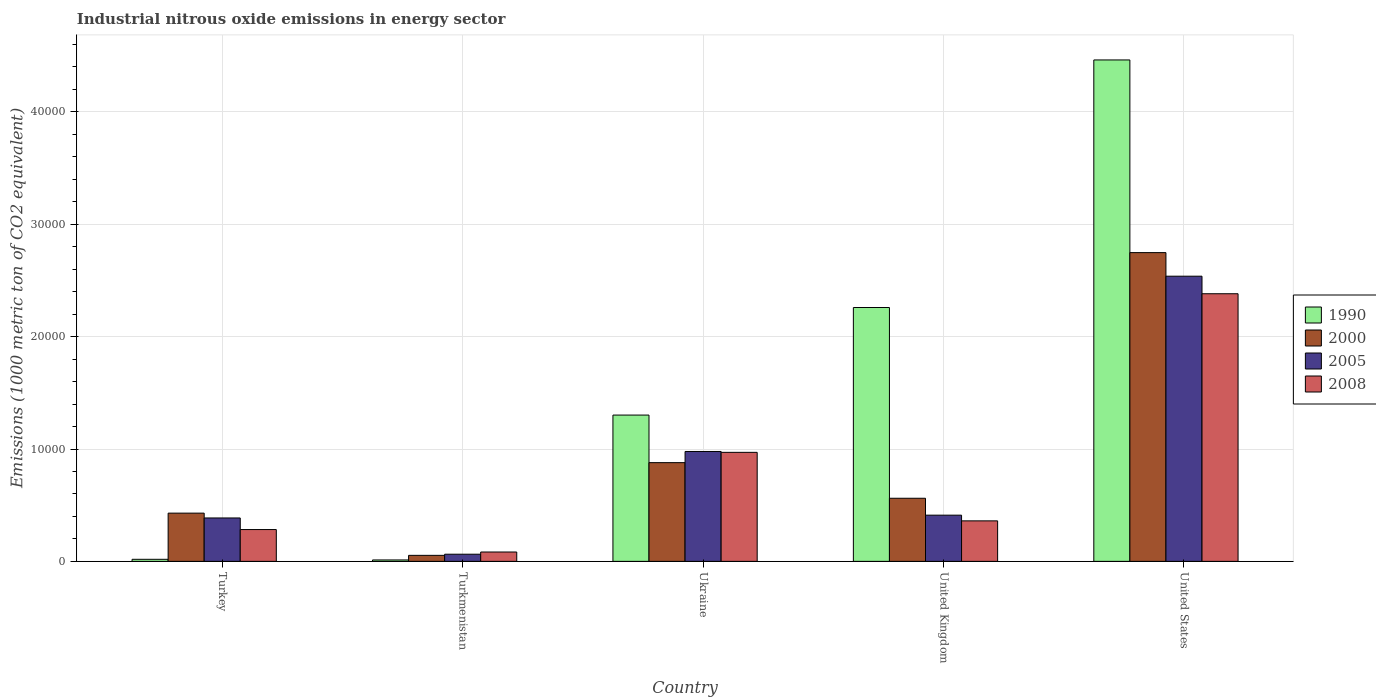How many different coloured bars are there?
Ensure brevity in your answer.  4. Are the number of bars on each tick of the X-axis equal?
Your answer should be compact. Yes. How many bars are there on the 5th tick from the right?
Provide a short and direct response. 4. What is the label of the 5th group of bars from the left?
Your answer should be very brief. United States. In how many cases, is the number of bars for a given country not equal to the number of legend labels?
Your answer should be very brief. 0. What is the amount of industrial nitrous oxide emitted in 1990 in United States?
Offer a terse response. 4.46e+04. Across all countries, what is the maximum amount of industrial nitrous oxide emitted in 1990?
Offer a very short reply. 4.46e+04. Across all countries, what is the minimum amount of industrial nitrous oxide emitted in 2005?
Your answer should be very brief. 637.2. In which country was the amount of industrial nitrous oxide emitted in 2005 maximum?
Offer a terse response. United States. In which country was the amount of industrial nitrous oxide emitted in 2008 minimum?
Your answer should be compact. Turkmenistan. What is the total amount of industrial nitrous oxide emitted in 1990 in the graph?
Make the answer very short. 8.05e+04. What is the difference between the amount of industrial nitrous oxide emitted in 2008 in Turkey and that in United States?
Ensure brevity in your answer.  -2.10e+04. What is the difference between the amount of industrial nitrous oxide emitted in 2000 in United Kingdom and the amount of industrial nitrous oxide emitted in 2005 in United States?
Ensure brevity in your answer.  -1.98e+04. What is the average amount of industrial nitrous oxide emitted in 2005 per country?
Offer a terse response. 8753.94. What is the difference between the amount of industrial nitrous oxide emitted of/in 1990 and amount of industrial nitrous oxide emitted of/in 2000 in Ukraine?
Make the answer very short. 4235.2. What is the ratio of the amount of industrial nitrous oxide emitted in 2000 in Ukraine to that in United Kingdom?
Keep it short and to the point. 1.56. Is the difference between the amount of industrial nitrous oxide emitted in 1990 in Ukraine and United States greater than the difference between the amount of industrial nitrous oxide emitted in 2000 in Ukraine and United States?
Your answer should be compact. No. What is the difference between the highest and the second highest amount of industrial nitrous oxide emitted in 2008?
Offer a very short reply. 2.02e+04. What is the difference between the highest and the lowest amount of industrial nitrous oxide emitted in 2000?
Provide a succinct answer. 2.69e+04. In how many countries, is the amount of industrial nitrous oxide emitted in 2000 greater than the average amount of industrial nitrous oxide emitted in 2000 taken over all countries?
Ensure brevity in your answer.  1. Is the sum of the amount of industrial nitrous oxide emitted in 2005 in Turkey and Turkmenistan greater than the maximum amount of industrial nitrous oxide emitted in 2000 across all countries?
Give a very brief answer. No. Are all the bars in the graph horizontal?
Provide a short and direct response. No. Are the values on the major ticks of Y-axis written in scientific E-notation?
Your response must be concise. No. Does the graph contain grids?
Ensure brevity in your answer.  Yes. Where does the legend appear in the graph?
Your answer should be compact. Center right. How many legend labels are there?
Your answer should be very brief. 4. What is the title of the graph?
Give a very brief answer. Industrial nitrous oxide emissions in energy sector. Does "1973" appear as one of the legend labels in the graph?
Give a very brief answer. No. What is the label or title of the Y-axis?
Your response must be concise. Emissions (1000 metric ton of CO2 equivalent). What is the Emissions (1000 metric ton of CO2 equivalent) of 1990 in Turkey?
Provide a short and direct response. 183.6. What is the Emissions (1000 metric ton of CO2 equivalent) in 2000 in Turkey?
Offer a very short reply. 4292. What is the Emissions (1000 metric ton of CO2 equivalent) of 2005 in Turkey?
Your answer should be very brief. 3862.7. What is the Emissions (1000 metric ton of CO2 equivalent) of 2008 in Turkey?
Ensure brevity in your answer.  2831.3. What is the Emissions (1000 metric ton of CO2 equivalent) of 1990 in Turkmenistan?
Provide a succinct answer. 125.6. What is the Emissions (1000 metric ton of CO2 equivalent) of 2000 in Turkmenistan?
Keep it short and to the point. 535.7. What is the Emissions (1000 metric ton of CO2 equivalent) of 2005 in Turkmenistan?
Your answer should be compact. 637.2. What is the Emissions (1000 metric ton of CO2 equivalent) of 2008 in Turkmenistan?
Your answer should be very brief. 832.5. What is the Emissions (1000 metric ton of CO2 equivalent) in 1990 in Ukraine?
Your answer should be very brief. 1.30e+04. What is the Emissions (1000 metric ton of CO2 equivalent) of 2000 in Ukraine?
Keep it short and to the point. 8784.8. What is the Emissions (1000 metric ton of CO2 equivalent) of 2005 in Ukraine?
Ensure brevity in your answer.  9779.9. What is the Emissions (1000 metric ton of CO2 equivalent) of 2008 in Ukraine?
Your response must be concise. 9701.8. What is the Emissions (1000 metric ton of CO2 equivalent) in 1990 in United Kingdom?
Make the answer very short. 2.26e+04. What is the Emissions (1000 metric ton of CO2 equivalent) in 2000 in United Kingdom?
Provide a succinct answer. 5616. What is the Emissions (1000 metric ton of CO2 equivalent) of 2005 in United Kingdom?
Your answer should be compact. 4111.2. What is the Emissions (1000 metric ton of CO2 equivalent) in 2008 in United Kingdom?
Give a very brief answer. 3604.6. What is the Emissions (1000 metric ton of CO2 equivalent) in 1990 in United States?
Your answer should be compact. 4.46e+04. What is the Emissions (1000 metric ton of CO2 equivalent) in 2000 in United States?
Your answer should be very brief. 2.75e+04. What is the Emissions (1000 metric ton of CO2 equivalent) in 2005 in United States?
Keep it short and to the point. 2.54e+04. What is the Emissions (1000 metric ton of CO2 equivalent) in 2008 in United States?
Provide a short and direct response. 2.38e+04. Across all countries, what is the maximum Emissions (1000 metric ton of CO2 equivalent) of 1990?
Your response must be concise. 4.46e+04. Across all countries, what is the maximum Emissions (1000 metric ton of CO2 equivalent) of 2000?
Ensure brevity in your answer.  2.75e+04. Across all countries, what is the maximum Emissions (1000 metric ton of CO2 equivalent) of 2005?
Provide a succinct answer. 2.54e+04. Across all countries, what is the maximum Emissions (1000 metric ton of CO2 equivalent) in 2008?
Give a very brief answer. 2.38e+04. Across all countries, what is the minimum Emissions (1000 metric ton of CO2 equivalent) in 1990?
Provide a succinct answer. 125.6. Across all countries, what is the minimum Emissions (1000 metric ton of CO2 equivalent) in 2000?
Ensure brevity in your answer.  535.7. Across all countries, what is the minimum Emissions (1000 metric ton of CO2 equivalent) in 2005?
Provide a succinct answer. 637.2. Across all countries, what is the minimum Emissions (1000 metric ton of CO2 equivalent) of 2008?
Provide a short and direct response. 832.5. What is the total Emissions (1000 metric ton of CO2 equivalent) of 1990 in the graph?
Provide a succinct answer. 8.05e+04. What is the total Emissions (1000 metric ton of CO2 equivalent) of 2000 in the graph?
Offer a terse response. 4.67e+04. What is the total Emissions (1000 metric ton of CO2 equivalent) of 2005 in the graph?
Offer a terse response. 4.38e+04. What is the total Emissions (1000 metric ton of CO2 equivalent) of 2008 in the graph?
Make the answer very short. 4.08e+04. What is the difference between the Emissions (1000 metric ton of CO2 equivalent) in 1990 in Turkey and that in Turkmenistan?
Your answer should be very brief. 58. What is the difference between the Emissions (1000 metric ton of CO2 equivalent) of 2000 in Turkey and that in Turkmenistan?
Make the answer very short. 3756.3. What is the difference between the Emissions (1000 metric ton of CO2 equivalent) of 2005 in Turkey and that in Turkmenistan?
Your response must be concise. 3225.5. What is the difference between the Emissions (1000 metric ton of CO2 equivalent) in 2008 in Turkey and that in Turkmenistan?
Keep it short and to the point. 1998.8. What is the difference between the Emissions (1000 metric ton of CO2 equivalent) in 1990 in Turkey and that in Ukraine?
Provide a short and direct response. -1.28e+04. What is the difference between the Emissions (1000 metric ton of CO2 equivalent) in 2000 in Turkey and that in Ukraine?
Give a very brief answer. -4492.8. What is the difference between the Emissions (1000 metric ton of CO2 equivalent) in 2005 in Turkey and that in Ukraine?
Offer a very short reply. -5917.2. What is the difference between the Emissions (1000 metric ton of CO2 equivalent) in 2008 in Turkey and that in Ukraine?
Ensure brevity in your answer.  -6870.5. What is the difference between the Emissions (1000 metric ton of CO2 equivalent) in 1990 in Turkey and that in United Kingdom?
Give a very brief answer. -2.24e+04. What is the difference between the Emissions (1000 metric ton of CO2 equivalent) of 2000 in Turkey and that in United Kingdom?
Provide a short and direct response. -1324. What is the difference between the Emissions (1000 metric ton of CO2 equivalent) of 2005 in Turkey and that in United Kingdom?
Make the answer very short. -248.5. What is the difference between the Emissions (1000 metric ton of CO2 equivalent) in 2008 in Turkey and that in United Kingdom?
Your response must be concise. -773.3. What is the difference between the Emissions (1000 metric ton of CO2 equivalent) in 1990 in Turkey and that in United States?
Offer a very short reply. -4.44e+04. What is the difference between the Emissions (1000 metric ton of CO2 equivalent) of 2000 in Turkey and that in United States?
Offer a very short reply. -2.32e+04. What is the difference between the Emissions (1000 metric ton of CO2 equivalent) of 2005 in Turkey and that in United States?
Your answer should be compact. -2.15e+04. What is the difference between the Emissions (1000 metric ton of CO2 equivalent) in 2008 in Turkey and that in United States?
Provide a succinct answer. -2.10e+04. What is the difference between the Emissions (1000 metric ton of CO2 equivalent) in 1990 in Turkmenistan and that in Ukraine?
Your response must be concise. -1.29e+04. What is the difference between the Emissions (1000 metric ton of CO2 equivalent) of 2000 in Turkmenistan and that in Ukraine?
Ensure brevity in your answer.  -8249.1. What is the difference between the Emissions (1000 metric ton of CO2 equivalent) of 2005 in Turkmenistan and that in Ukraine?
Offer a very short reply. -9142.7. What is the difference between the Emissions (1000 metric ton of CO2 equivalent) of 2008 in Turkmenistan and that in Ukraine?
Make the answer very short. -8869.3. What is the difference between the Emissions (1000 metric ton of CO2 equivalent) in 1990 in Turkmenistan and that in United Kingdom?
Your answer should be very brief. -2.25e+04. What is the difference between the Emissions (1000 metric ton of CO2 equivalent) in 2000 in Turkmenistan and that in United Kingdom?
Keep it short and to the point. -5080.3. What is the difference between the Emissions (1000 metric ton of CO2 equivalent) of 2005 in Turkmenistan and that in United Kingdom?
Provide a succinct answer. -3474. What is the difference between the Emissions (1000 metric ton of CO2 equivalent) of 2008 in Turkmenistan and that in United Kingdom?
Offer a very short reply. -2772.1. What is the difference between the Emissions (1000 metric ton of CO2 equivalent) in 1990 in Turkmenistan and that in United States?
Provide a succinct answer. -4.45e+04. What is the difference between the Emissions (1000 metric ton of CO2 equivalent) of 2000 in Turkmenistan and that in United States?
Your response must be concise. -2.69e+04. What is the difference between the Emissions (1000 metric ton of CO2 equivalent) in 2005 in Turkmenistan and that in United States?
Offer a terse response. -2.47e+04. What is the difference between the Emissions (1000 metric ton of CO2 equivalent) of 2008 in Turkmenistan and that in United States?
Your answer should be compact. -2.30e+04. What is the difference between the Emissions (1000 metric ton of CO2 equivalent) in 1990 in Ukraine and that in United Kingdom?
Your response must be concise. -9573. What is the difference between the Emissions (1000 metric ton of CO2 equivalent) of 2000 in Ukraine and that in United Kingdom?
Give a very brief answer. 3168.8. What is the difference between the Emissions (1000 metric ton of CO2 equivalent) in 2005 in Ukraine and that in United Kingdom?
Offer a very short reply. 5668.7. What is the difference between the Emissions (1000 metric ton of CO2 equivalent) in 2008 in Ukraine and that in United Kingdom?
Your answer should be compact. 6097.2. What is the difference between the Emissions (1000 metric ton of CO2 equivalent) in 1990 in Ukraine and that in United States?
Give a very brief answer. -3.16e+04. What is the difference between the Emissions (1000 metric ton of CO2 equivalent) in 2000 in Ukraine and that in United States?
Provide a succinct answer. -1.87e+04. What is the difference between the Emissions (1000 metric ton of CO2 equivalent) in 2005 in Ukraine and that in United States?
Your answer should be compact. -1.56e+04. What is the difference between the Emissions (1000 metric ton of CO2 equivalent) in 2008 in Ukraine and that in United States?
Your answer should be very brief. -1.41e+04. What is the difference between the Emissions (1000 metric ton of CO2 equivalent) of 1990 in United Kingdom and that in United States?
Your response must be concise. -2.20e+04. What is the difference between the Emissions (1000 metric ton of CO2 equivalent) in 2000 in United Kingdom and that in United States?
Your answer should be compact. -2.19e+04. What is the difference between the Emissions (1000 metric ton of CO2 equivalent) in 2005 in United Kingdom and that in United States?
Offer a terse response. -2.13e+04. What is the difference between the Emissions (1000 metric ton of CO2 equivalent) of 2008 in United Kingdom and that in United States?
Give a very brief answer. -2.02e+04. What is the difference between the Emissions (1000 metric ton of CO2 equivalent) of 1990 in Turkey and the Emissions (1000 metric ton of CO2 equivalent) of 2000 in Turkmenistan?
Your answer should be very brief. -352.1. What is the difference between the Emissions (1000 metric ton of CO2 equivalent) of 1990 in Turkey and the Emissions (1000 metric ton of CO2 equivalent) of 2005 in Turkmenistan?
Give a very brief answer. -453.6. What is the difference between the Emissions (1000 metric ton of CO2 equivalent) in 1990 in Turkey and the Emissions (1000 metric ton of CO2 equivalent) in 2008 in Turkmenistan?
Offer a terse response. -648.9. What is the difference between the Emissions (1000 metric ton of CO2 equivalent) in 2000 in Turkey and the Emissions (1000 metric ton of CO2 equivalent) in 2005 in Turkmenistan?
Give a very brief answer. 3654.8. What is the difference between the Emissions (1000 metric ton of CO2 equivalent) in 2000 in Turkey and the Emissions (1000 metric ton of CO2 equivalent) in 2008 in Turkmenistan?
Make the answer very short. 3459.5. What is the difference between the Emissions (1000 metric ton of CO2 equivalent) in 2005 in Turkey and the Emissions (1000 metric ton of CO2 equivalent) in 2008 in Turkmenistan?
Provide a succinct answer. 3030.2. What is the difference between the Emissions (1000 metric ton of CO2 equivalent) of 1990 in Turkey and the Emissions (1000 metric ton of CO2 equivalent) of 2000 in Ukraine?
Offer a very short reply. -8601.2. What is the difference between the Emissions (1000 metric ton of CO2 equivalent) in 1990 in Turkey and the Emissions (1000 metric ton of CO2 equivalent) in 2005 in Ukraine?
Your answer should be compact. -9596.3. What is the difference between the Emissions (1000 metric ton of CO2 equivalent) in 1990 in Turkey and the Emissions (1000 metric ton of CO2 equivalent) in 2008 in Ukraine?
Ensure brevity in your answer.  -9518.2. What is the difference between the Emissions (1000 metric ton of CO2 equivalent) in 2000 in Turkey and the Emissions (1000 metric ton of CO2 equivalent) in 2005 in Ukraine?
Keep it short and to the point. -5487.9. What is the difference between the Emissions (1000 metric ton of CO2 equivalent) in 2000 in Turkey and the Emissions (1000 metric ton of CO2 equivalent) in 2008 in Ukraine?
Offer a very short reply. -5409.8. What is the difference between the Emissions (1000 metric ton of CO2 equivalent) of 2005 in Turkey and the Emissions (1000 metric ton of CO2 equivalent) of 2008 in Ukraine?
Offer a terse response. -5839.1. What is the difference between the Emissions (1000 metric ton of CO2 equivalent) in 1990 in Turkey and the Emissions (1000 metric ton of CO2 equivalent) in 2000 in United Kingdom?
Provide a short and direct response. -5432.4. What is the difference between the Emissions (1000 metric ton of CO2 equivalent) of 1990 in Turkey and the Emissions (1000 metric ton of CO2 equivalent) of 2005 in United Kingdom?
Provide a short and direct response. -3927.6. What is the difference between the Emissions (1000 metric ton of CO2 equivalent) in 1990 in Turkey and the Emissions (1000 metric ton of CO2 equivalent) in 2008 in United Kingdom?
Provide a short and direct response. -3421. What is the difference between the Emissions (1000 metric ton of CO2 equivalent) in 2000 in Turkey and the Emissions (1000 metric ton of CO2 equivalent) in 2005 in United Kingdom?
Give a very brief answer. 180.8. What is the difference between the Emissions (1000 metric ton of CO2 equivalent) of 2000 in Turkey and the Emissions (1000 metric ton of CO2 equivalent) of 2008 in United Kingdom?
Keep it short and to the point. 687.4. What is the difference between the Emissions (1000 metric ton of CO2 equivalent) of 2005 in Turkey and the Emissions (1000 metric ton of CO2 equivalent) of 2008 in United Kingdom?
Provide a short and direct response. 258.1. What is the difference between the Emissions (1000 metric ton of CO2 equivalent) in 1990 in Turkey and the Emissions (1000 metric ton of CO2 equivalent) in 2000 in United States?
Your answer should be compact. -2.73e+04. What is the difference between the Emissions (1000 metric ton of CO2 equivalent) of 1990 in Turkey and the Emissions (1000 metric ton of CO2 equivalent) of 2005 in United States?
Make the answer very short. -2.52e+04. What is the difference between the Emissions (1000 metric ton of CO2 equivalent) of 1990 in Turkey and the Emissions (1000 metric ton of CO2 equivalent) of 2008 in United States?
Keep it short and to the point. -2.36e+04. What is the difference between the Emissions (1000 metric ton of CO2 equivalent) in 2000 in Turkey and the Emissions (1000 metric ton of CO2 equivalent) in 2005 in United States?
Provide a succinct answer. -2.11e+04. What is the difference between the Emissions (1000 metric ton of CO2 equivalent) in 2000 in Turkey and the Emissions (1000 metric ton of CO2 equivalent) in 2008 in United States?
Offer a very short reply. -1.95e+04. What is the difference between the Emissions (1000 metric ton of CO2 equivalent) of 2005 in Turkey and the Emissions (1000 metric ton of CO2 equivalent) of 2008 in United States?
Provide a short and direct response. -2.00e+04. What is the difference between the Emissions (1000 metric ton of CO2 equivalent) in 1990 in Turkmenistan and the Emissions (1000 metric ton of CO2 equivalent) in 2000 in Ukraine?
Keep it short and to the point. -8659.2. What is the difference between the Emissions (1000 metric ton of CO2 equivalent) of 1990 in Turkmenistan and the Emissions (1000 metric ton of CO2 equivalent) of 2005 in Ukraine?
Make the answer very short. -9654.3. What is the difference between the Emissions (1000 metric ton of CO2 equivalent) in 1990 in Turkmenistan and the Emissions (1000 metric ton of CO2 equivalent) in 2008 in Ukraine?
Your answer should be compact. -9576.2. What is the difference between the Emissions (1000 metric ton of CO2 equivalent) of 2000 in Turkmenistan and the Emissions (1000 metric ton of CO2 equivalent) of 2005 in Ukraine?
Keep it short and to the point. -9244.2. What is the difference between the Emissions (1000 metric ton of CO2 equivalent) in 2000 in Turkmenistan and the Emissions (1000 metric ton of CO2 equivalent) in 2008 in Ukraine?
Your answer should be compact. -9166.1. What is the difference between the Emissions (1000 metric ton of CO2 equivalent) of 2005 in Turkmenistan and the Emissions (1000 metric ton of CO2 equivalent) of 2008 in Ukraine?
Make the answer very short. -9064.6. What is the difference between the Emissions (1000 metric ton of CO2 equivalent) of 1990 in Turkmenistan and the Emissions (1000 metric ton of CO2 equivalent) of 2000 in United Kingdom?
Provide a short and direct response. -5490.4. What is the difference between the Emissions (1000 metric ton of CO2 equivalent) in 1990 in Turkmenistan and the Emissions (1000 metric ton of CO2 equivalent) in 2005 in United Kingdom?
Provide a succinct answer. -3985.6. What is the difference between the Emissions (1000 metric ton of CO2 equivalent) of 1990 in Turkmenistan and the Emissions (1000 metric ton of CO2 equivalent) of 2008 in United Kingdom?
Offer a very short reply. -3479. What is the difference between the Emissions (1000 metric ton of CO2 equivalent) in 2000 in Turkmenistan and the Emissions (1000 metric ton of CO2 equivalent) in 2005 in United Kingdom?
Provide a succinct answer. -3575.5. What is the difference between the Emissions (1000 metric ton of CO2 equivalent) in 2000 in Turkmenistan and the Emissions (1000 metric ton of CO2 equivalent) in 2008 in United Kingdom?
Provide a succinct answer. -3068.9. What is the difference between the Emissions (1000 metric ton of CO2 equivalent) in 2005 in Turkmenistan and the Emissions (1000 metric ton of CO2 equivalent) in 2008 in United Kingdom?
Keep it short and to the point. -2967.4. What is the difference between the Emissions (1000 metric ton of CO2 equivalent) in 1990 in Turkmenistan and the Emissions (1000 metric ton of CO2 equivalent) in 2000 in United States?
Your answer should be compact. -2.74e+04. What is the difference between the Emissions (1000 metric ton of CO2 equivalent) in 1990 in Turkmenistan and the Emissions (1000 metric ton of CO2 equivalent) in 2005 in United States?
Your answer should be compact. -2.53e+04. What is the difference between the Emissions (1000 metric ton of CO2 equivalent) in 1990 in Turkmenistan and the Emissions (1000 metric ton of CO2 equivalent) in 2008 in United States?
Offer a terse response. -2.37e+04. What is the difference between the Emissions (1000 metric ton of CO2 equivalent) in 2000 in Turkmenistan and the Emissions (1000 metric ton of CO2 equivalent) in 2005 in United States?
Provide a short and direct response. -2.48e+04. What is the difference between the Emissions (1000 metric ton of CO2 equivalent) in 2000 in Turkmenistan and the Emissions (1000 metric ton of CO2 equivalent) in 2008 in United States?
Provide a succinct answer. -2.33e+04. What is the difference between the Emissions (1000 metric ton of CO2 equivalent) of 2005 in Turkmenistan and the Emissions (1000 metric ton of CO2 equivalent) of 2008 in United States?
Provide a succinct answer. -2.32e+04. What is the difference between the Emissions (1000 metric ton of CO2 equivalent) in 1990 in Ukraine and the Emissions (1000 metric ton of CO2 equivalent) in 2000 in United Kingdom?
Keep it short and to the point. 7404. What is the difference between the Emissions (1000 metric ton of CO2 equivalent) in 1990 in Ukraine and the Emissions (1000 metric ton of CO2 equivalent) in 2005 in United Kingdom?
Provide a short and direct response. 8908.8. What is the difference between the Emissions (1000 metric ton of CO2 equivalent) of 1990 in Ukraine and the Emissions (1000 metric ton of CO2 equivalent) of 2008 in United Kingdom?
Your answer should be very brief. 9415.4. What is the difference between the Emissions (1000 metric ton of CO2 equivalent) of 2000 in Ukraine and the Emissions (1000 metric ton of CO2 equivalent) of 2005 in United Kingdom?
Provide a short and direct response. 4673.6. What is the difference between the Emissions (1000 metric ton of CO2 equivalent) of 2000 in Ukraine and the Emissions (1000 metric ton of CO2 equivalent) of 2008 in United Kingdom?
Offer a terse response. 5180.2. What is the difference between the Emissions (1000 metric ton of CO2 equivalent) of 2005 in Ukraine and the Emissions (1000 metric ton of CO2 equivalent) of 2008 in United Kingdom?
Your answer should be very brief. 6175.3. What is the difference between the Emissions (1000 metric ton of CO2 equivalent) of 1990 in Ukraine and the Emissions (1000 metric ton of CO2 equivalent) of 2000 in United States?
Your response must be concise. -1.45e+04. What is the difference between the Emissions (1000 metric ton of CO2 equivalent) of 1990 in Ukraine and the Emissions (1000 metric ton of CO2 equivalent) of 2005 in United States?
Provide a short and direct response. -1.24e+04. What is the difference between the Emissions (1000 metric ton of CO2 equivalent) of 1990 in Ukraine and the Emissions (1000 metric ton of CO2 equivalent) of 2008 in United States?
Give a very brief answer. -1.08e+04. What is the difference between the Emissions (1000 metric ton of CO2 equivalent) in 2000 in Ukraine and the Emissions (1000 metric ton of CO2 equivalent) in 2005 in United States?
Provide a succinct answer. -1.66e+04. What is the difference between the Emissions (1000 metric ton of CO2 equivalent) in 2000 in Ukraine and the Emissions (1000 metric ton of CO2 equivalent) in 2008 in United States?
Give a very brief answer. -1.50e+04. What is the difference between the Emissions (1000 metric ton of CO2 equivalent) of 2005 in Ukraine and the Emissions (1000 metric ton of CO2 equivalent) of 2008 in United States?
Your answer should be compact. -1.40e+04. What is the difference between the Emissions (1000 metric ton of CO2 equivalent) of 1990 in United Kingdom and the Emissions (1000 metric ton of CO2 equivalent) of 2000 in United States?
Keep it short and to the point. -4884.9. What is the difference between the Emissions (1000 metric ton of CO2 equivalent) in 1990 in United Kingdom and the Emissions (1000 metric ton of CO2 equivalent) in 2005 in United States?
Make the answer very short. -2785.7. What is the difference between the Emissions (1000 metric ton of CO2 equivalent) of 1990 in United Kingdom and the Emissions (1000 metric ton of CO2 equivalent) of 2008 in United States?
Provide a short and direct response. -1224.8. What is the difference between the Emissions (1000 metric ton of CO2 equivalent) of 2000 in United Kingdom and the Emissions (1000 metric ton of CO2 equivalent) of 2005 in United States?
Your answer should be very brief. -1.98e+04. What is the difference between the Emissions (1000 metric ton of CO2 equivalent) of 2000 in United Kingdom and the Emissions (1000 metric ton of CO2 equivalent) of 2008 in United States?
Ensure brevity in your answer.  -1.82e+04. What is the difference between the Emissions (1000 metric ton of CO2 equivalent) in 2005 in United Kingdom and the Emissions (1000 metric ton of CO2 equivalent) in 2008 in United States?
Provide a succinct answer. -1.97e+04. What is the average Emissions (1000 metric ton of CO2 equivalent) in 1990 per country?
Your answer should be compact. 1.61e+04. What is the average Emissions (1000 metric ton of CO2 equivalent) in 2000 per country?
Your answer should be very brief. 9341.28. What is the average Emissions (1000 metric ton of CO2 equivalent) of 2005 per country?
Provide a succinct answer. 8753.94. What is the average Emissions (1000 metric ton of CO2 equivalent) of 2008 per country?
Your response must be concise. 8157.6. What is the difference between the Emissions (1000 metric ton of CO2 equivalent) of 1990 and Emissions (1000 metric ton of CO2 equivalent) of 2000 in Turkey?
Give a very brief answer. -4108.4. What is the difference between the Emissions (1000 metric ton of CO2 equivalent) in 1990 and Emissions (1000 metric ton of CO2 equivalent) in 2005 in Turkey?
Keep it short and to the point. -3679.1. What is the difference between the Emissions (1000 metric ton of CO2 equivalent) of 1990 and Emissions (1000 metric ton of CO2 equivalent) of 2008 in Turkey?
Make the answer very short. -2647.7. What is the difference between the Emissions (1000 metric ton of CO2 equivalent) in 2000 and Emissions (1000 metric ton of CO2 equivalent) in 2005 in Turkey?
Offer a very short reply. 429.3. What is the difference between the Emissions (1000 metric ton of CO2 equivalent) in 2000 and Emissions (1000 metric ton of CO2 equivalent) in 2008 in Turkey?
Ensure brevity in your answer.  1460.7. What is the difference between the Emissions (1000 metric ton of CO2 equivalent) of 2005 and Emissions (1000 metric ton of CO2 equivalent) of 2008 in Turkey?
Offer a terse response. 1031.4. What is the difference between the Emissions (1000 metric ton of CO2 equivalent) in 1990 and Emissions (1000 metric ton of CO2 equivalent) in 2000 in Turkmenistan?
Your answer should be very brief. -410.1. What is the difference between the Emissions (1000 metric ton of CO2 equivalent) of 1990 and Emissions (1000 metric ton of CO2 equivalent) of 2005 in Turkmenistan?
Make the answer very short. -511.6. What is the difference between the Emissions (1000 metric ton of CO2 equivalent) in 1990 and Emissions (1000 metric ton of CO2 equivalent) in 2008 in Turkmenistan?
Keep it short and to the point. -706.9. What is the difference between the Emissions (1000 metric ton of CO2 equivalent) in 2000 and Emissions (1000 metric ton of CO2 equivalent) in 2005 in Turkmenistan?
Offer a terse response. -101.5. What is the difference between the Emissions (1000 metric ton of CO2 equivalent) in 2000 and Emissions (1000 metric ton of CO2 equivalent) in 2008 in Turkmenistan?
Your response must be concise. -296.8. What is the difference between the Emissions (1000 metric ton of CO2 equivalent) in 2005 and Emissions (1000 metric ton of CO2 equivalent) in 2008 in Turkmenistan?
Ensure brevity in your answer.  -195.3. What is the difference between the Emissions (1000 metric ton of CO2 equivalent) of 1990 and Emissions (1000 metric ton of CO2 equivalent) of 2000 in Ukraine?
Your response must be concise. 4235.2. What is the difference between the Emissions (1000 metric ton of CO2 equivalent) of 1990 and Emissions (1000 metric ton of CO2 equivalent) of 2005 in Ukraine?
Give a very brief answer. 3240.1. What is the difference between the Emissions (1000 metric ton of CO2 equivalent) in 1990 and Emissions (1000 metric ton of CO2 equivalent) in 2008 in Ukraine?
Make the answer very short. 3318.2. What is the difference between the Emissions (1000 metric ton of CO2 equivalent) in 2000 and Emissions (1000 metric ton of CO2 equivalent) in 2005 in Ukraine?
Provide a succinct answer. -995.1. What is the difference between the Emissions (1000 metric ton of CO2 equivalent) in 2000 and Emissions (1000 metric ton of CO2 equivalent) in 2008 in Ukraine?
Keep it short and to the point. -917. What is the difference between the Emissions (1000 metric ton of CO2 equivalent) in 2005 and Emissions (1000 metric ton of CO2 equivalent) in 2008 in Ukraine?
Ensure brevity in your answer.  78.1. What is the difference between the Emissions (1000 metric ton of CO2 equivalent) of 1990 and Emissions (1000 metric ton of CO2 equivalent) of 2000 in United Kingdom?
Offer a terse response. 1.70e+04. What is the difference between the Emissions (1000 metric ton of CO2 equivalent) of 1990 and Emissions (1000 metric ton of CO2 equivalent) of 2005 in United Kingdom?
Provide a short and direct response. 1.85e+04. What is the difference between the Emissions (1000 metric ton of CO2 equivalent) in 1990 and Emissions (1000 metric ton of CO2 equivalent) in 2008 in United Kingdom?
Keep it short and to the point. 1.90e+04. What is the difference between the Emissions (1000 metric ton of CO2 equivalent) in 2000 and Emissions (1000 metric ton of CO2 equivalent) in 2005 in United Kingdom?
Keep it short and to the point. 1504.8. What is the difference between the Emissions (1000 metric ton of CO2 equivalent) of 2000 and Emissions (1000 metric ton of CO2 equivalent) of 2008 in United Kingdom?
Give a very brief answer. 2011.4. What is the difference between the Emissions (1000 metric ton of CO2 equivalent) in 2005 and Emissions (1000 metric ton of CO2 equivalent) in 2008 in United Kingdom?
Offer a very short reply. 506.6. What is the difference between the Emissions (1000 metric ton of CO2 equivalent) in 1990 and Emissions (1000 metric ton of CO2 equivalent) in 2000 in United States?
Your answer should be very brief. 1.71e+04. What is the difference between the Emissions (1000 metric ton of CO2 equivalent) in 1990 and Emissions (1000 metric ton of CO2 equivalent) in 2005 in United States?
Provide a succinct answer. 1.92e+04. What is the difference between the Emissions (1000 metric ton of CO2 equivalent) of 1990 and Emissions (1000 metric ton of CO2 equivalent) of 2008 in United States?
Provide a short and direct response. 2.08e+04. What is the difference between the Emissions (1000 metric ton of CO2 equivalent) of 2000 and Emissions (1000 metric ton of CO2 equivalent) of 2005 in United States?
Your answer should be very brief. 2099.2. What is the difference between the Emissions (1000 metric ton of CO2 equivalent) of 2000 and Emissions (1000 metric ton of CO2 equivalent) of 2008 in United States?
Make the answer very short. 3660.1. What is the difference between the Emissions (1000 metric ton of CO2 equivalent) of 2005 and Emissions (1000 metric ton of CO2 equivalent) of 2008 in United States?
Keep it short and to the point. 1560.9. What is the ratio of the Emissions (1000 metric ton of CO2 equivalent) in 1990 in Turkey to that in Turkmenistan?
Your answer should be very brief. 1.46. What is the ratio of the Emissions (1000 metric ton of CO2 equivalent) of 2000 in Turkey to that in Turkmenistan?
Provide a succinct answer. 8.01. What is the ratio of the Emissions (1000 metric ton of CO2 equivalent) of 2005 in Turkey to that in Turkmenistan?
Your response must be concise. 6.06. What is the ratio of the Emissions (1000 metric ton of CO2 equivalent) in 2008 in Turkey to that in Turkmenistan?
Your answer should be very brief. 3.4. What is the ratio of the Emissions (1000 metric ton of CO2 equivalent) in 1990 in Turkey to that in Ukraine?
Your answer should be very brief. 0.01. What is the ratio of the Emissions (1000 metric ton of CO2 equivalent) in 2000 in Turkey to that in Ukraine?
Give a very brief answer. 0.49. What is the ratio of the Emissions (1000 metric ton of CO2 equivalent) in 2005 in Turkey to that in Ukraine?
Your answer should be compact. 0.4. What is the ratio of the Emissions (1000 metric ton of CO2 equivalent) in 2008 in Turkey to that in Ukraine?
Your answer should be compact. 0.29. What is the ratio of the Emissions (1000 metric ton of CO2 equivalent) of 1990 in Turkey to that in United Kingdom?
Provide a succinct answer. 0.01. What is the ratio of the Emissions (1000 metric ton of CO2 equivalent) of 2000 in Turkey to that in United Kingdom?
Make the answer very short. 0.76. What is the ratio of the Emissions (1000 metric ton of CO2 equivalent) in 2005 in Turkey to that in United Kingdom?
Ensure brevity in your answer.  0.94. What is the ratio of the Emissions (1000 metric ton of CO2 equivalent) of 2008 in Turkey to that in United Kingdom?
Provide a succinct answer. 0.79. What is the ratio of the Emissions (1000 metric ton of CO2 equivalent) of 1990 in Turkey to that in United States?
Your answer should be very brief. 0. What is the ratio of the Emissions (1000 metric ton of CO2 equivalent) in 2000 in Turkey to that in United States?
Offer a terse response. 0.16. What is the ratio of the Emissions (1000 metric ton of CO2 equivalent) of 2005 in Turkey to that in United States?
Offer a very short reply. 0.15. What is the ratio of the Emissions (1000 metric ton of CO2 equivalent) in 2008 in Turkey to that in United States?
Offer a terse response. 0.12. What is the ratio of the Emissions (1000 metric ton of CO2 equivalent) of 1990 in Turkmenistan to that in Ukraine?
Your answer should be compact. 0.01. What is the ratio of the Emissions (1000 metric ton of CO2 equivalent) in 2000 in Turkmenistan to that in Ukraine?
Your response must be concise. 0.06. What is the ratio of the Emissions (1000 metric ton of CO2 equivalent) in 2005 in Turkmenistan to that in Ukraine?
Offer a terse response. 0.07. What is the ratio of the Emissions (1000 metric ton of CO2 equivalent) of 2008 in Turkmenistan to that in Ukraine?
Offer a very short reply. 0.09. What is the ratio of the Emissions (1000 metric ton of CO2 equivalent) in 1990 in Turkmenistan to that in United Kingdom?
Make the answer very short. 0.01. What is the ratio of the Emissions (1000 metric ton of CO2 equivalent) in 2000 in Turkmenistan to that in United Kingdom?
Keep it short and to the point. 0.1. What is the ratio of the Emissions (1000 metric ton of CO2 equivalent) of 2005 in Turkmenistan to that in United Kingdom?
Your answer should be very brief. 0.15. What is the ratio of the Emissions (1000 metric ton of CO2 equivalent) of 2008 in Turkmenistan to that in United Kingdom?
Ensure brevity in your answer.  0.23. What is the ratio of the Emissions (1000 metric ton of CO2 equivalent) in 1990 in Turkmenistan to that in United States?
Your response must be concise. 0. What is the ratio of the Emissions (1000 metric ton of CO2 equivalent) of 2000 in Turkmenistan to that in United States?
Offer a terse response. 0.02. What is the ratio of the Emissions (1000 metric ton of CO2 equivalent) of 2005 in Turkmenistan to that in United States?
Your answer should be very brief. 0.03. What is the ratio of the Emissions (1000 metric ton of CO2 equivalent) in 2008 in Turkmenistan to that in United States?
Your answer should be compact. 0.04. What is the ratio of the Emissions (1000 metric ton of CO2 equivalent) of 1990 in Ukraine to that in United Kingdom?
Give a very brief answer. 0.58. What is the ratio of the Emissions (1000 metric ton of CO2 equivalent) of 2000 in Ukraine to that in United Kingdom?
Your answer should be very brief. 1.56. What is the ratio of the Emissions (1000 metric ton of CO2 equivalent) of 2005 in Ukraine to that in United Kingdom?
Your response must be concise. 2.38. What is the ratio of the Emissions (1000 metric ton of CO2 equivalent) in 2008 in Ukraine to that in United Kingdom?
Your answer should be very brief. 2.69. What is the ratio of the Emissions (1000 metric ton of CO2 equivalent) of 1990 in Ukraine to that in United States?
Offer a terse response. 0.29. What is the ratio of the Emissions (1000 metric ton of CO2 equivalent) of 2000 in Ukraine to that in United States?
Your answer should be very brief. 0.32. What is the ratio of the Emissions (1000 metric ton of CO2 equivalent) in 2005 in Ukraine to that in United States?
Offer a terse response. 0.39. What is the ratio of the Emissions (1000 metric ton of CO2 equivalent) of 2008 in Ukraine to that in United States?
Provide a short and direct response. 0.41. What is the ratio of the Emissions (1000 metric ton of CO2 equivalent) of 1990 in United Kingdom to that in United States?
Provide a succinct answer. 0.51. What is the ratio of the Emissions (1000 metric ton of CO2 equivalent) in 2000 in United Kingdom to that in United States?
Ensure brevity in your answer.  0.2. What is the ratio of the Emissions (1000 metric ton of CO2 equivalent) of 2005 in United Kingdom to that in United States?
Provide a succinct answer. 0.16. What is the ratio of the Emissions (1000 metric ton of CO2 equivalent) of 2008 in United Kingdom to that in United States?
Provide a succinct answer. 0.15. What is the difference between the highest and the second highest Emissions (1000 metric ton of CO2 equivalent) of 1990?
Give a very brief answer. 2.20e+04. What is the difference between the highest and the second highest Emissions (1000 metric ton of CO2 equivalent) in 2000?
Provide a succinct answer. 1.87e+04. What is the difference between the highest and the second highest Emissions (1000 metric ton of CO2 equivalent) in 2005?
Keep it short and to the point. 1.56e+04. What is the difference between the highest and the second highest Emissions (1000 metric ton of CO2 equivalent) of 2008?
Offer a very short reply. 1.41e+04. What is the difference between the highest and the lowest Emissions (1000 metric ton of CO2 equivalent) in 1990?
Give a very brief answer. 4.45e+04. What is the difference between the highest and the lowest Emissions (1000 metric ton of CO2 equivalent) of 2000?
Your response must be concise. 2.69e+04. What is the difference between the highest and the lowest Emissions (1000 metric ton of CO2 equivalent) in 2005?
Your answer should be compact. 2.47e+04. What is the difference between the highest and the lowest Emissions (1000 metric ton of CO2 equivalent) of 2008?
Provide a short and direct response. 2.30e+04. 